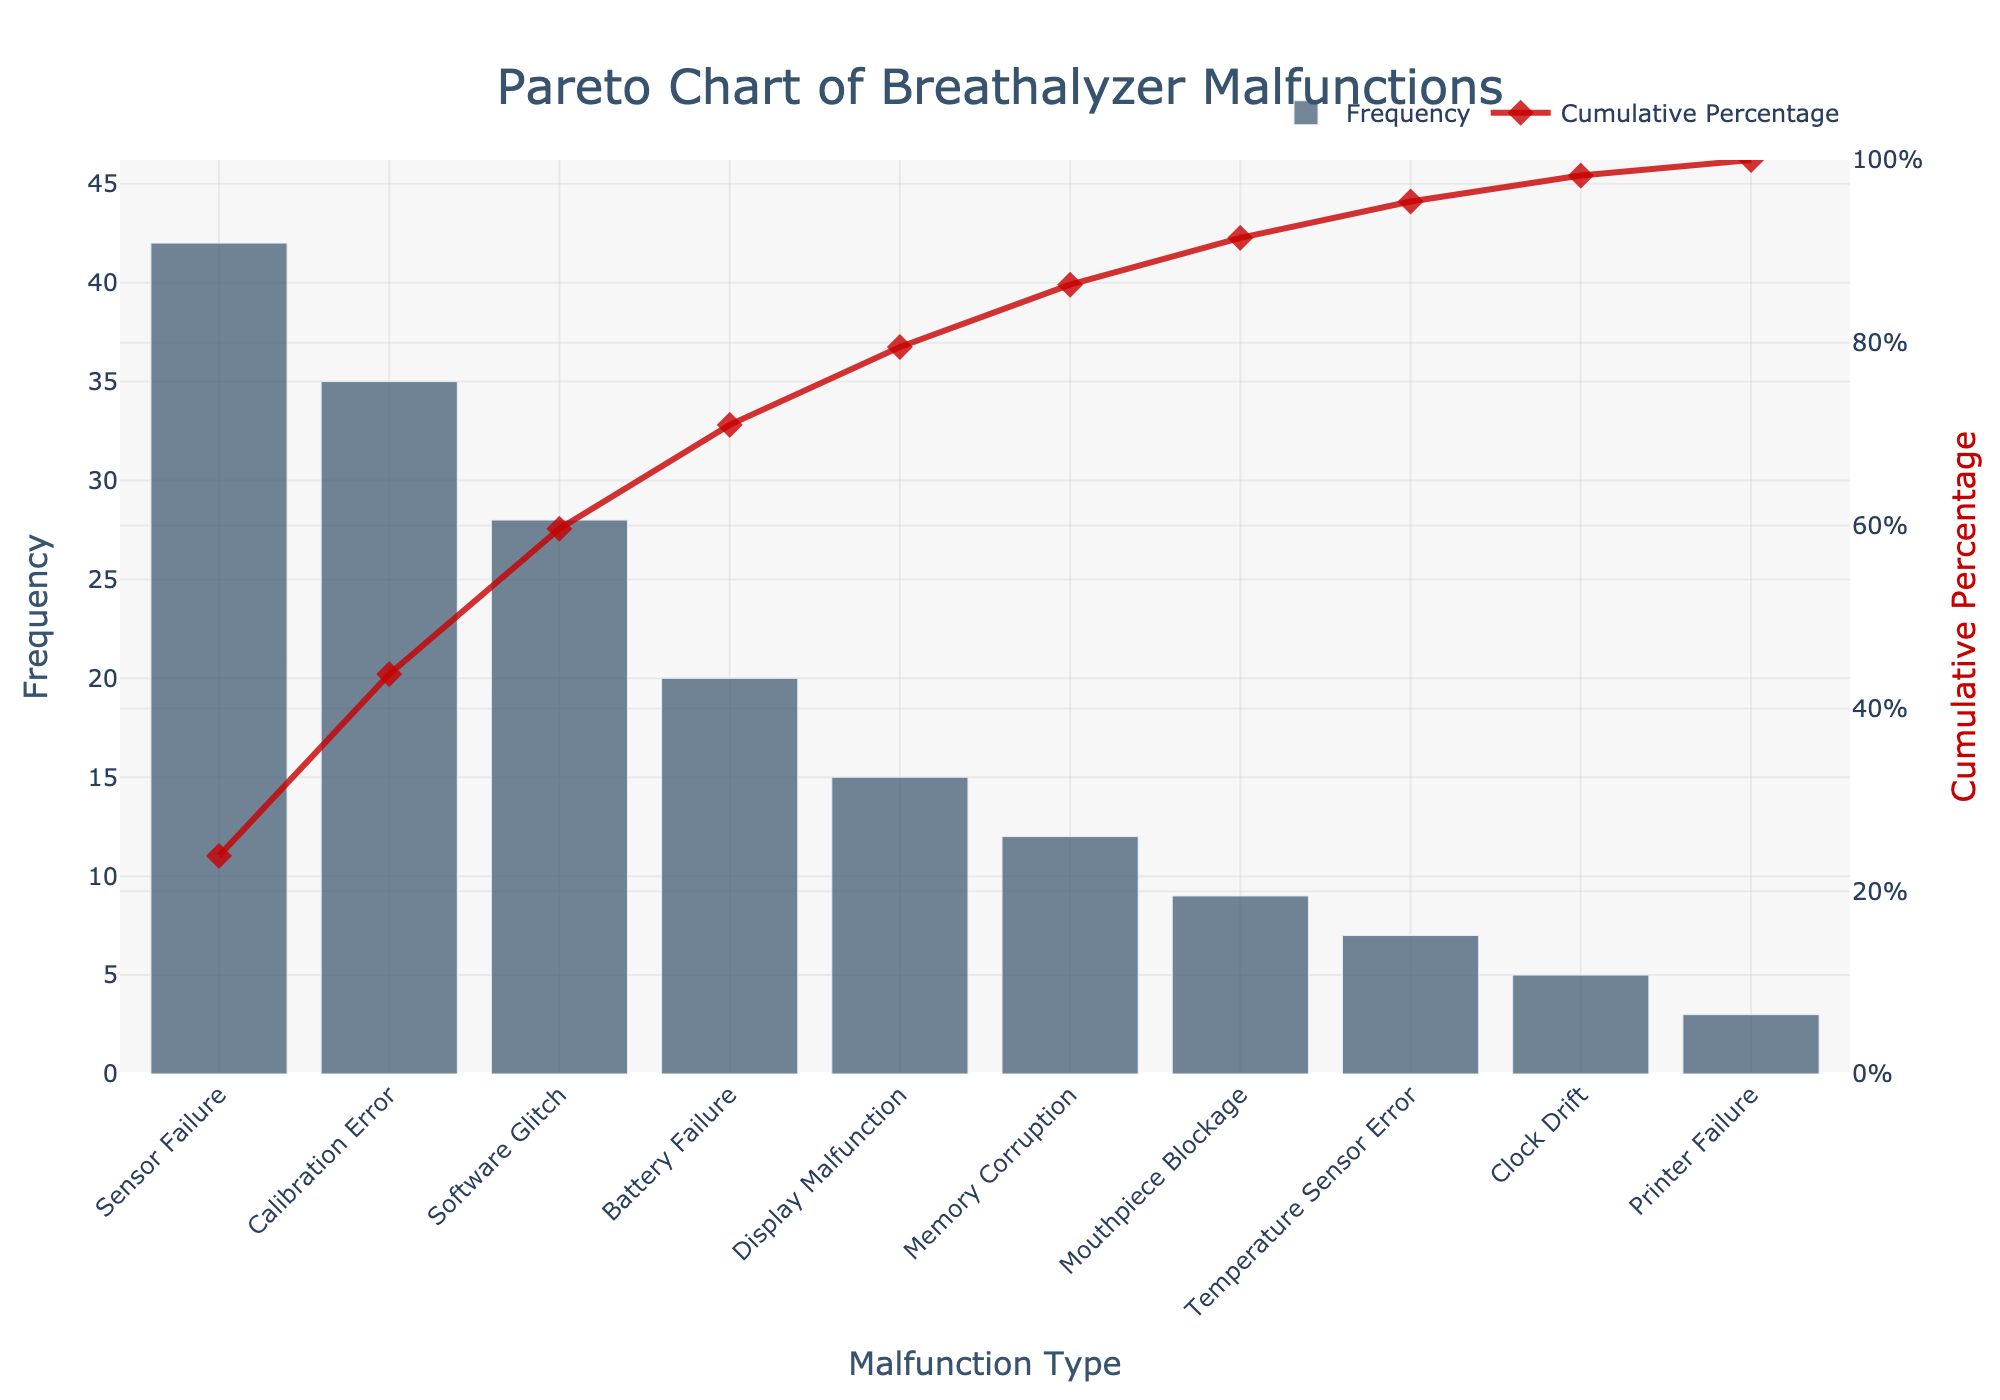What is the title of the figure? The title is typically located at the top of the figure and visually stands out due to its larger font size and prominence. In this figure, the title reads "Pareto Chart of Breathalyzer Malfunctions".
Answer: Pareto Chart of Breathalyzer Malfunctions What is the malfunction type with the highest frequency? The Pareto chart uses bars to represent frequencies, so the highest bar corresponds to the highest frequency. In this chart, "Sensor Failure" has the highest bar.
Answer: Sensor Failure How many malfunction types are represented in the figure? Counting the number of bars on the x-axis gives the total number of malfunction types. There are 10 bars, each representing a different malfunction type.
Answer: 10 What is the cumulative percentage for "Software Glitch"? The cumulative percentage line graph helps us find cumulative percentages. Locate "Software Glitch" on the x-axis and trace up to the cumulative percentage line. The value is around 63%.
Answer: ~63% Which malfunction type accounts for the lowest frequency? The shortest bar on the left y-axis signifies the lowest frequency. According to the chart, "Printer Failure" has the shortest bar.
Answer: Printer Failure What is the combined frequency of "Sensor Failure" and "Calibration Error"? Adding the frequencies of "Sensor Failure" and "Calibration Error", which are 42 and 35 respectively: 42 + 35 = 77.
Answer: 77 Which malfunction types combined account for approximately 80% of the cumulative percentage? To find the cumulative percentage close to 80%, locate the point on the cumulative percentage line graph and trace downwards. The types up to and including "Battery Failure" total around 80%.
Answer: Sensor Failure, Calibration Error, Software Glitch, Battery Failure Is "Memory Corruption" more frequent than "Mouthpiece Blockage"? Compare the heights of the bars for "Memory Corruption" and "Mouthpiece Blockage". "Memory Corruption" has a higher bar than "Mouthpiece Blockage", meaning it is more frequent.
Answer: Yes How many malfunction types have a frequency greater than 20? Count the number of bars that extend above the frequency value of 20 on the y-axis. Four bars exceed this threshold.
Answer: 4 What percentage of malfunctions are due to "Battery Failure" and types with higher frequencies? Identify the cumulative percentage at the "Battery Failure" bar, which sums up "Sensor Failure", "Calibration Error", "Software Glitch", and "Battery Failure." The cumulative percentage at this point is approximately 88%.
Answer: ~88% 